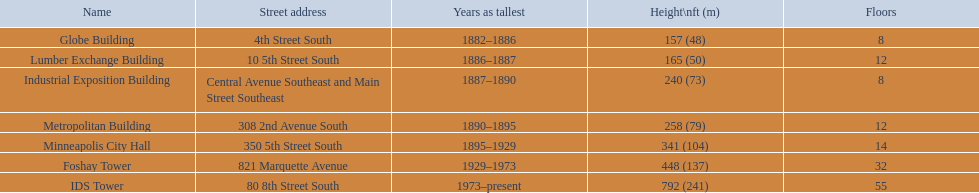In minneapolis, which structures are the highest? Globe Building, Lumber Exchange Building, Industrial Exposition Building, Metropolitan Building, Minneapolis City Hall, Foshay Tower, IDS Tower. Are there any with 8 levels? Globe Building, Industrial Exposition Building. If so, which one measures 240 feet in height? Industrial Exposition Building. 